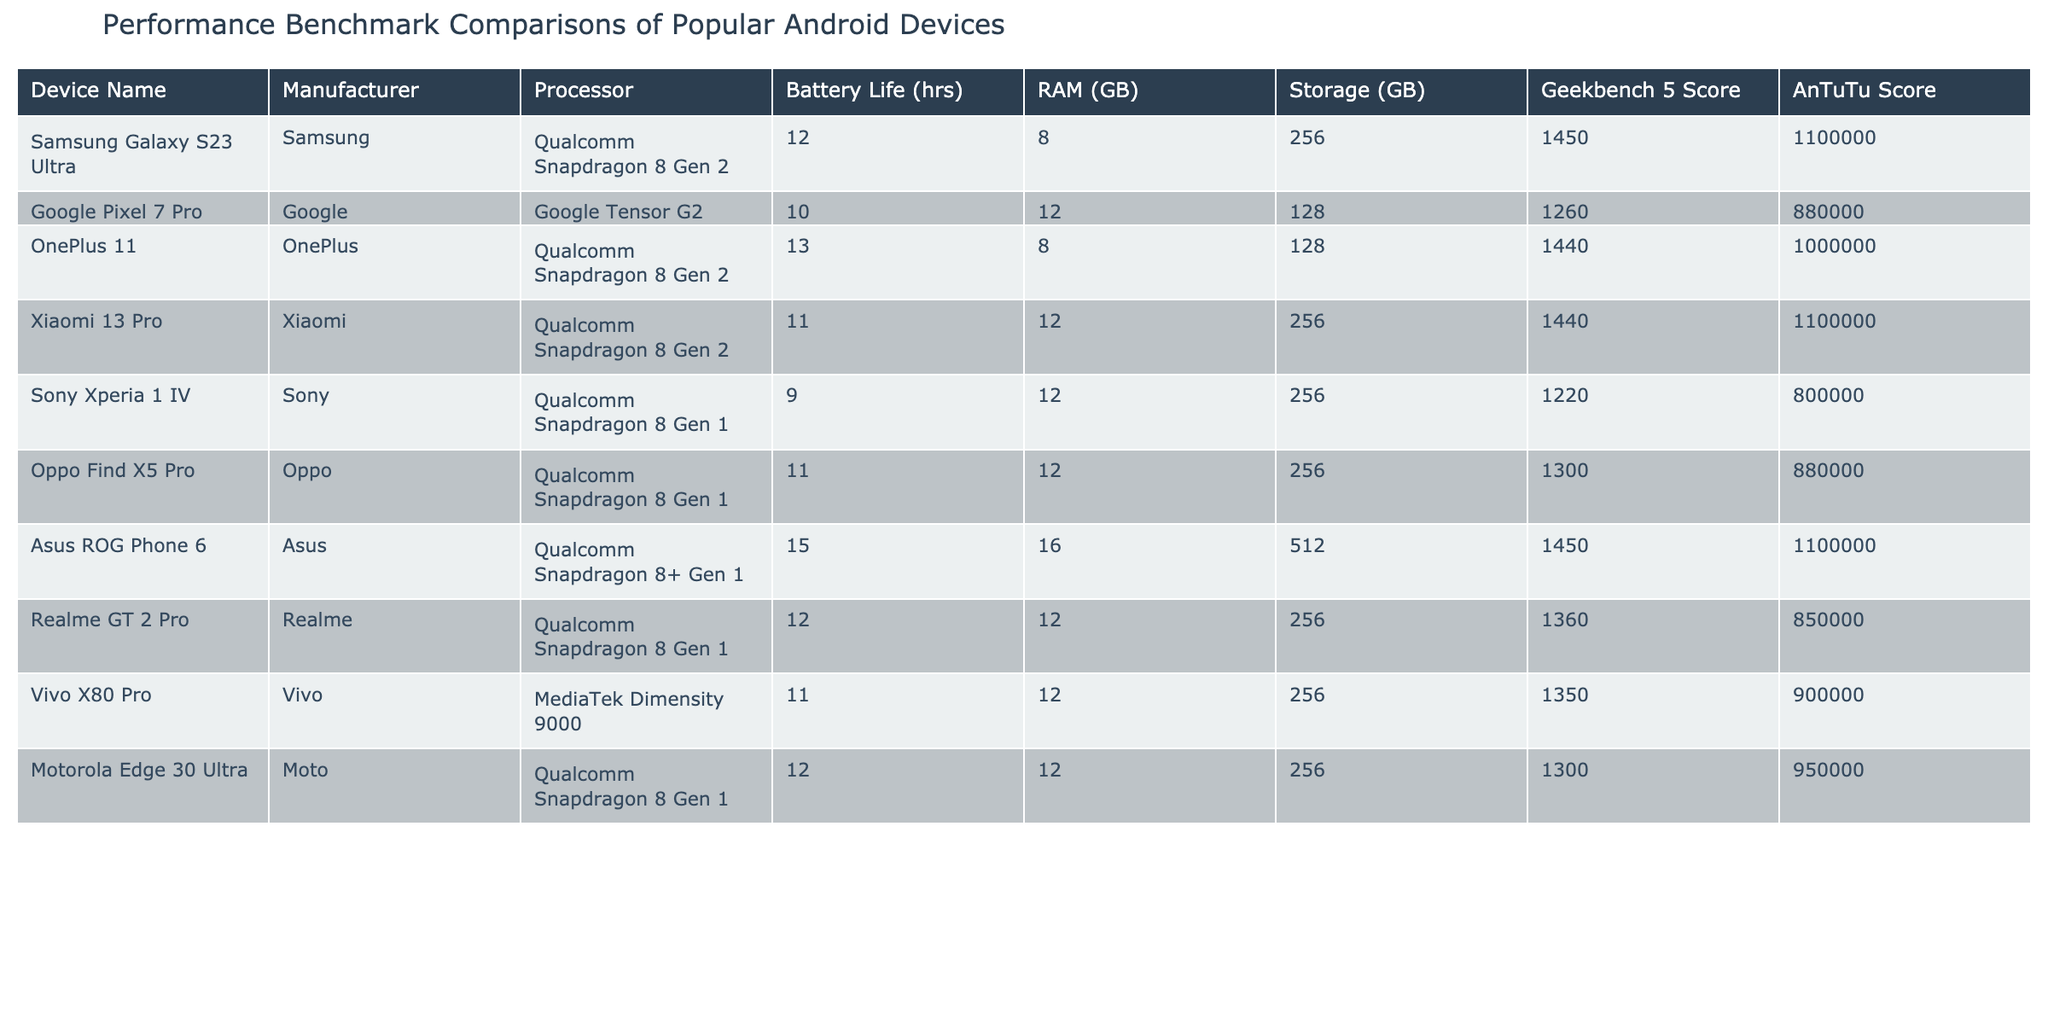What is the battery life of the Asus ROG Phone 6? In the table, find the row corresponding to the Asus ROG Phone 6. The battery life value listed in that row is 15 hours.
Answer: 15 hours Which device has the highest Geekbench 5 score? Look at the Geekbench 5 Score column and identify the maximum value. The highest score is 1450, which corresponds to both the Samsung Galaxy S23 Ultra and Asus ROG Phone 6.
Answer: Samsung Galaxy S23 Ultra, Asus ROG Phone 6 What is the average RAM of the devices listed? To calculate the average, sum all the RAM values: 8 + 12 + 8 + 12 + 12 + 12 + 16 + 12 + 12 + 12 = 128. There are 10 devices, so the average is 128 / 10 = 12.8 GB.
Answer: 12.8 GB Is the battery life of the Google Pixel 7 Pro greater than or equal to 11 hours? Check the battery life of the Google Pixel 7 Pro in the table, which is listed as 10 hours. Since 10 is less than 11, the answer is no.
Answer: No Which device has more RAM: the OnePlus 11 or the Xiaomi 13 Pro? Compare the RAM values in the corresponding rows. OnePlus 11 has 8 GB of RAM, while Xiaomi 13 Pro has 12 GB. Since 12 is greater than 8, Xiaomi 13 Pro has more RAM.
Answer: Xiaomi 13 Pro What is the total AnTuTu score of devices manufactured by Qualcomm? First, identify the devices with Qualcomm processors: Samsung Galaxy S23 Ultra, OnePlus 11, Xiaomi 13 Pro, Sony Xperia 1 IV, Oppo Find X5 Pro, Asus ROG Phone 6, Realme GT 2 Pro, Motorola Edge 30 Ultra. Their AnTuTu scores are: 1100000 + 1000000 + 1100000 + 800000 + 880000 + 1100000 + 850000 + 950000 = 8880000.
Answer: 8880000 What is the difference in battery life between the device with the longest and shortest battery life? The device with the longest battery life is the Asus ROG Phone 6 at 15 hours. The shortest battery life is for the Sony Xperia 1 IV at 9 hours. The difference is 15 - 9 = 6 hours.
Answer: 6 hours Does the Oppo Find X5 Pro have a higher Geekbench score than the Realme GT 2 Pro? Look at the Geekbench scores: Oppo Find X5 Pro has 1300, while Realme GT 2 Pro has 1360. Since 1300 is less than 1360, the answer is no.
Answer: No 